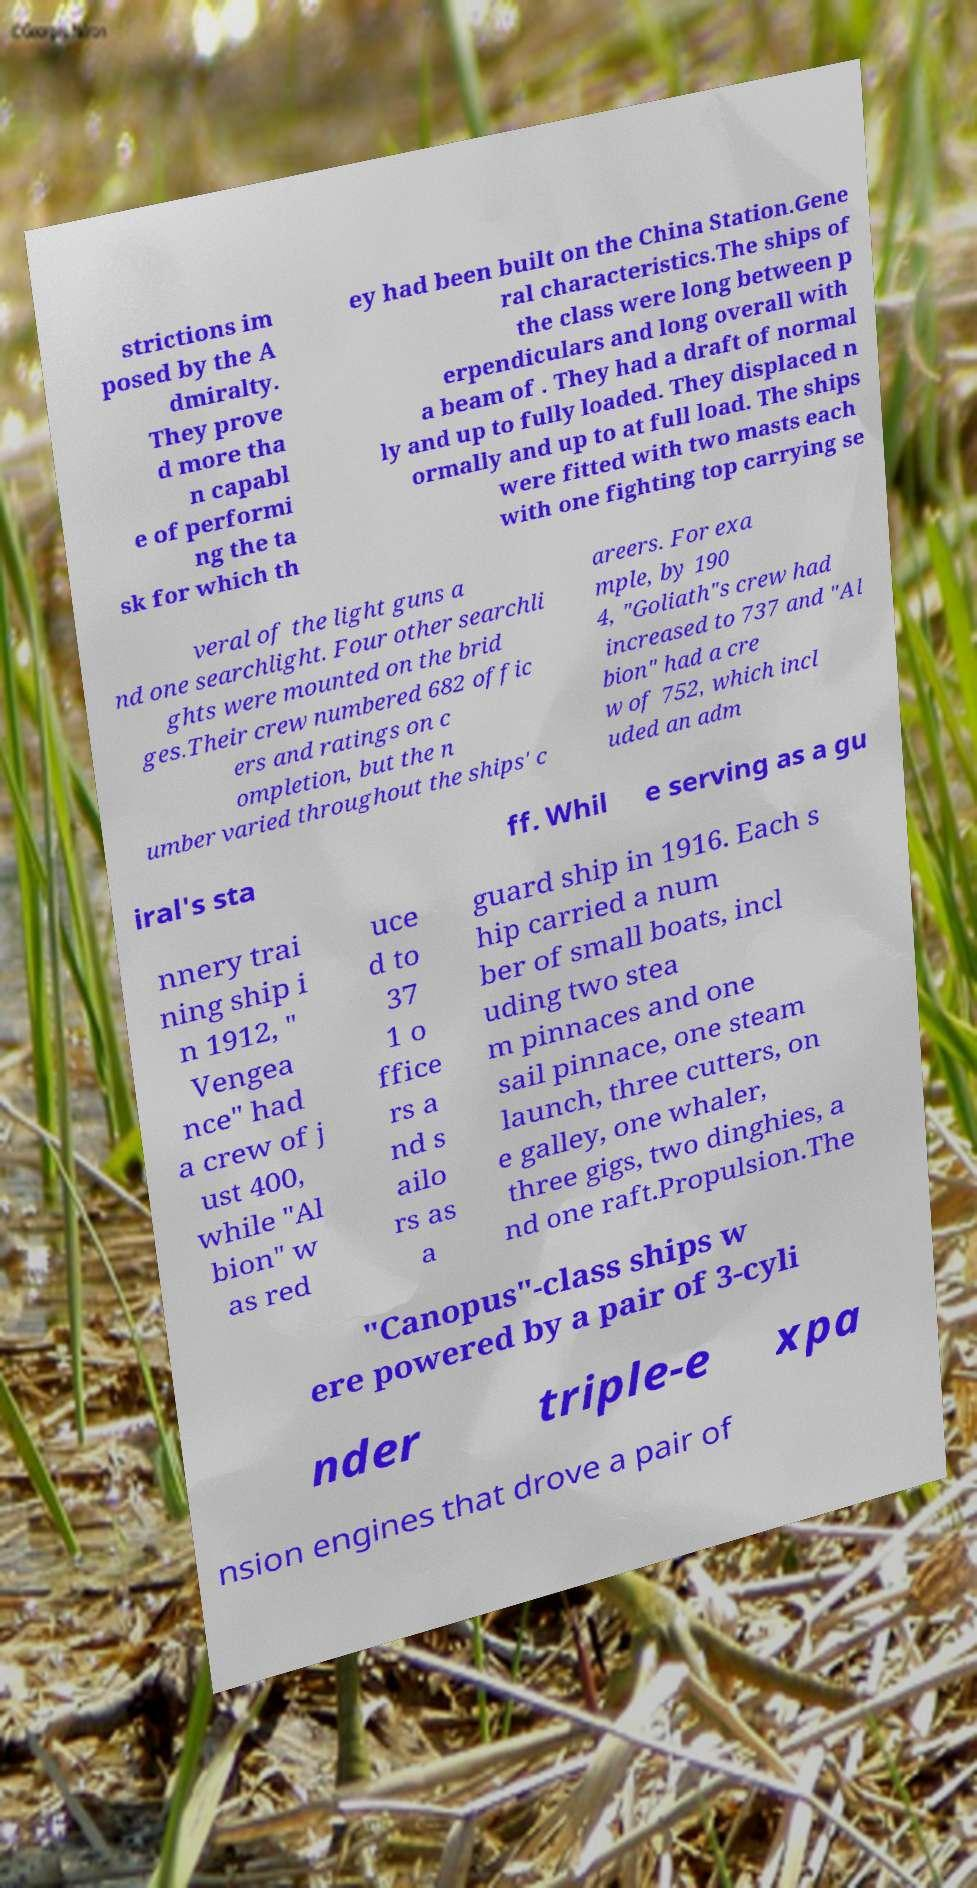Please read and relay the text visible in this image. What does it say? strictions im posed by the A dmiralty. They prove d more tha n capabl e of performi ng the ta sk for which th ey had been built on the China Station.Gene ral characteristics.The ships of the class were long between p erpendiculars and long overall with a beam of . They had a draft of normal ly and up to fully loaded. They displaced n ormally and up to at full load. The ships were fitted with two masts each with one fighting top carrying se veral of the light guns a nd one searchlight. Four other searchli ghts were mounted on the brid ges.Their crew numbered 682 offic ers and ratings on c ompletion, but the n umber varied throughout the ships' c areers. For exa mple, by 190 4, "Goliath"s crew had increased to 737 and "Al bion" had a cre w of 752, which incl uded an adm iral's sta ff. Whil e serving as a gu nnery trai ning ship i n 1912, " Vengea nce" had a crew of j ust 400, while "Al bion" w as red uce d to 37 1 o ffice rs a nd s ailo rs as a guard ship in 1916. Each s hip carried a num ber of small boats, incl uding two stea m pinnaces and one sail pinnace, one steam launch, three cutters, on e galley, one whaler, three gigs, two dinghies, a nd one raft.Propulsion.The "Canopus"-class ships w ere powered by a pair of 3-cyli nder triple-e xpa nsion engines that drove a pair of 